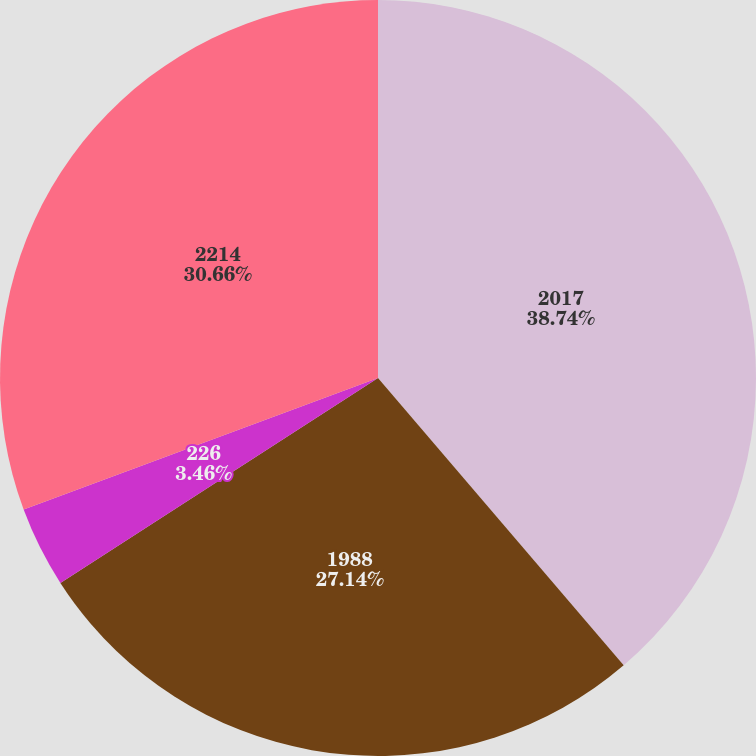Convert chart. <chart><loc_0><loc_0><loc_500><loc_500><pie_chart><fcel>2017<fcel>1988<fcel>226<fcel>2214<nl><fcel>38.74%<fcel>27.14%<fcel>3.46%<fcel>30.66%<nl></chart> 